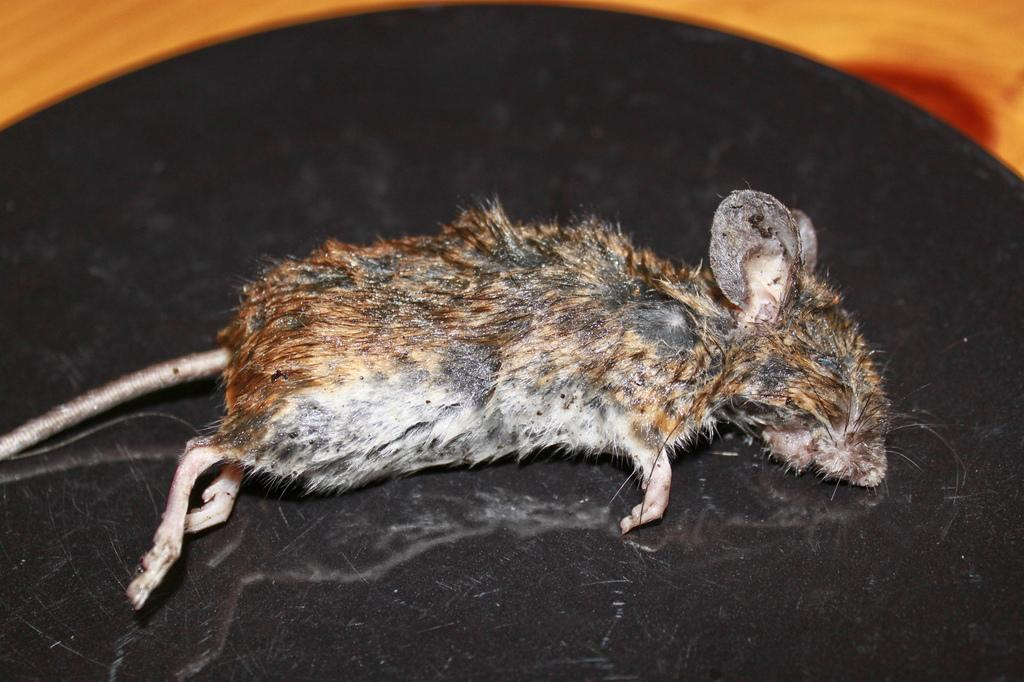What animal is the main subject of the image? There is a rat in the image. Where is the rat located in the image? The rat is in the center of the image. What is the rat doing in the image? The rat is sleeping. What type of drum can be seen in the image? There is no drum present in the image; it features a rat sleeping in the center. 